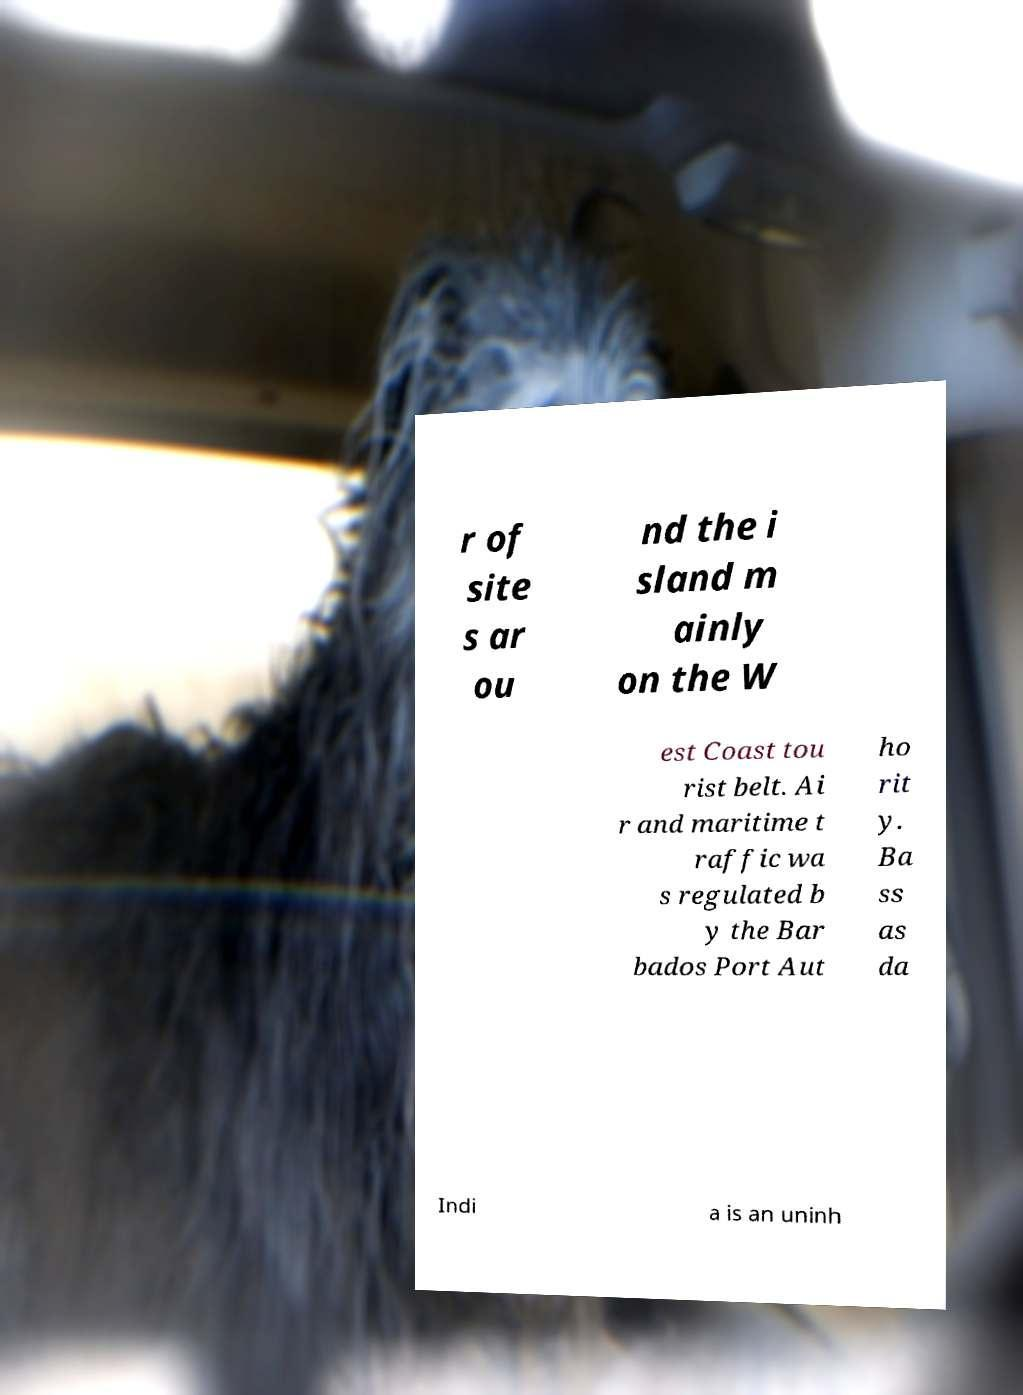Could you assist in decoding the text presented in this image and type it out clearly? r of site s ar ou nd the i sland m ainly on the W est Coast tou rist belt. Ai r and maritime t raffic wa s regulated b y the Bar bados Port Aut ho rit y. Ba ss as da Indi a is an uninh 